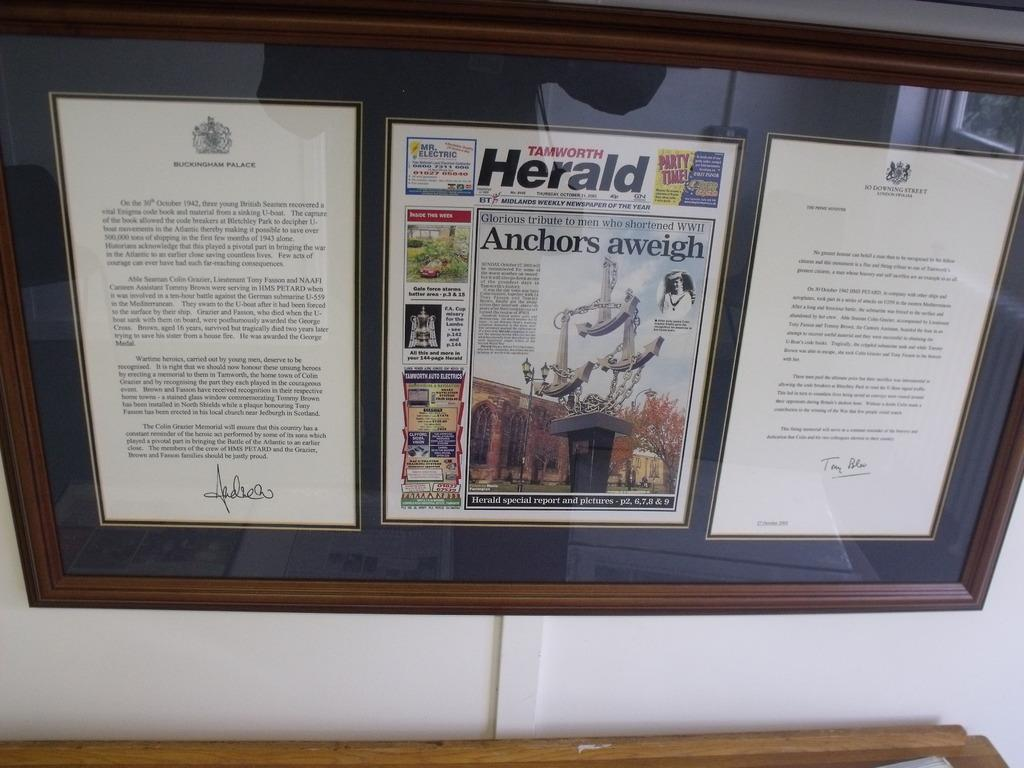<image>
Share a concise interpretation of the image provided. A page of the Tamworth Herald is framed between two other documents. 